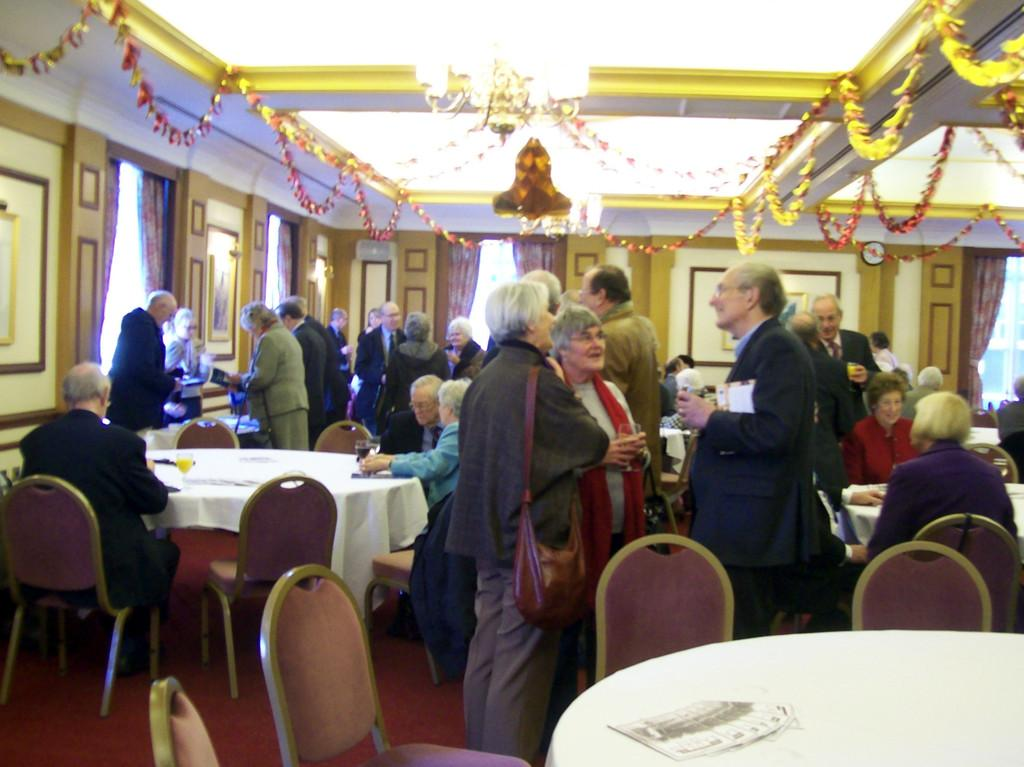How many people are in the image? There is a group of people in the image. What type of furniture is visible in the image? There are chairs and tables in the image. What can be seen in the background of the image? There is a wall in the background of the image, and a frame is attached to it. Where is the light located in the image? There is a light at the top of the image. Are there any trees visible in the image? There are no trees present in the image. Can you see any caves in the image? There are no caves present in the image. 